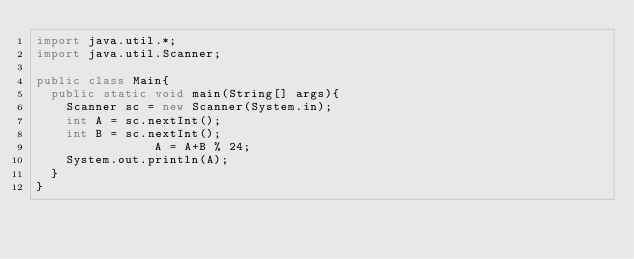Convert code to text. <code><loc_0><loc_0><loc_500><loc_500><_Java_>import java.util.*;
import java.util.Scanner;

public class Main{
	public static void main(String[] args){
		Scanner sc = new Scanner(System.in);
		int A = sc.nextInt();
		int B = sc.nextInt();
                A = A+B % 24;
		System.out.println(A);
	}
}</code> 